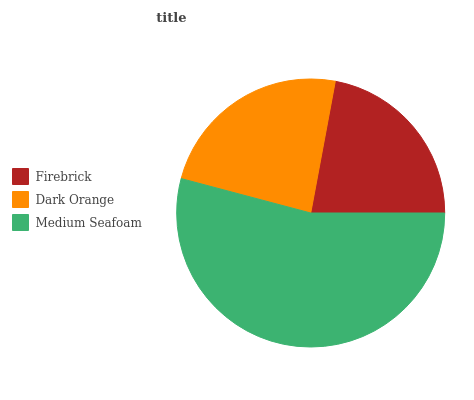Is Firebrick the minimum?
Answer yes or no. Yes. Is Medium Seafoam the maximum?
Answer yes or no. Yes. Is Dark Orange the minimum?
Answer yes or no. No. Is Dark Orange the maximum?
Answer yes or no. No. Is Dark Orange greater than Firebrick?
Answer yes or no. Yes. Is Firebrick less than Dark Orange?
Answer yes or no. Yes. Is Firebrick greater than Dark Orange?
Answer yes or no. No. Is Dark Orange less than Firebrick?
Answer yes or no. No. Is Dark Orange the high median?
Answer yes or no. Yes. Is Dark Orange the low median?
Answer yes or no. Yes. Is Firebrick the high median?
Answer yes or no. No. Is Medium Seafoam the low median?
Answer yes or no. No. 